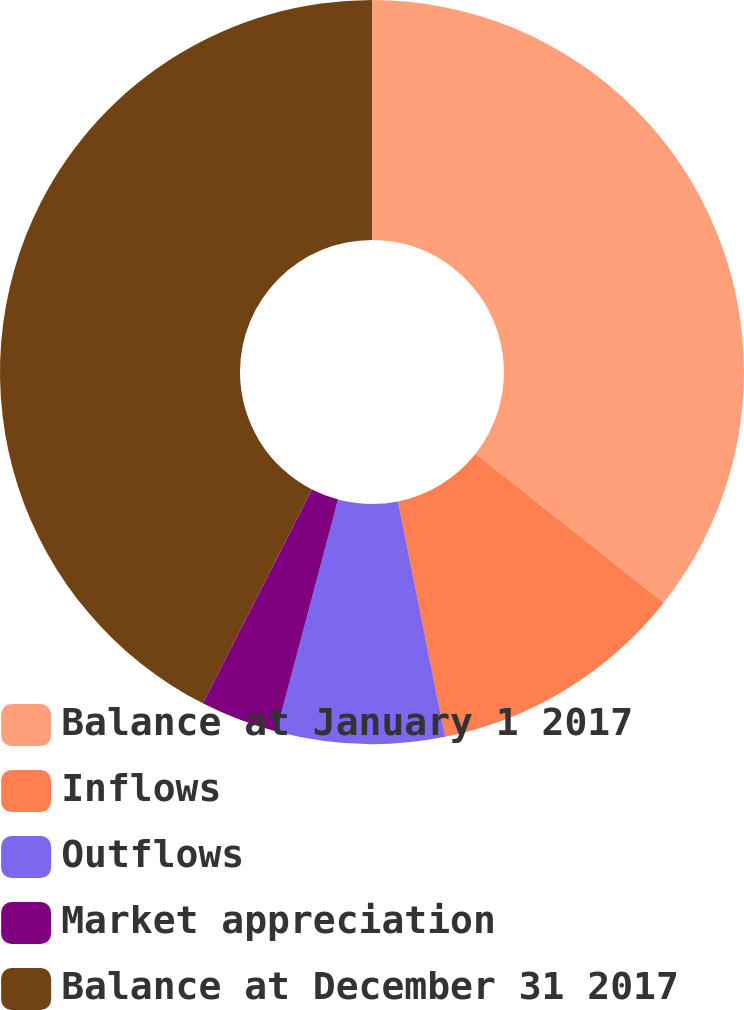Convert chart. <chart><loc_0><loc_0><loc_500><loc_500><pie_chart><fcel>Balance at January 1 2017<fcel>Inflows<fcel>Outflows<fcel>Market appreciation<fcel>Balance at December 31 2017<nl><fcel>35.65%<fcel>11.2%<fcel>7.29%<fcel>3.38%<fcel>42.49%<nl></chart> 